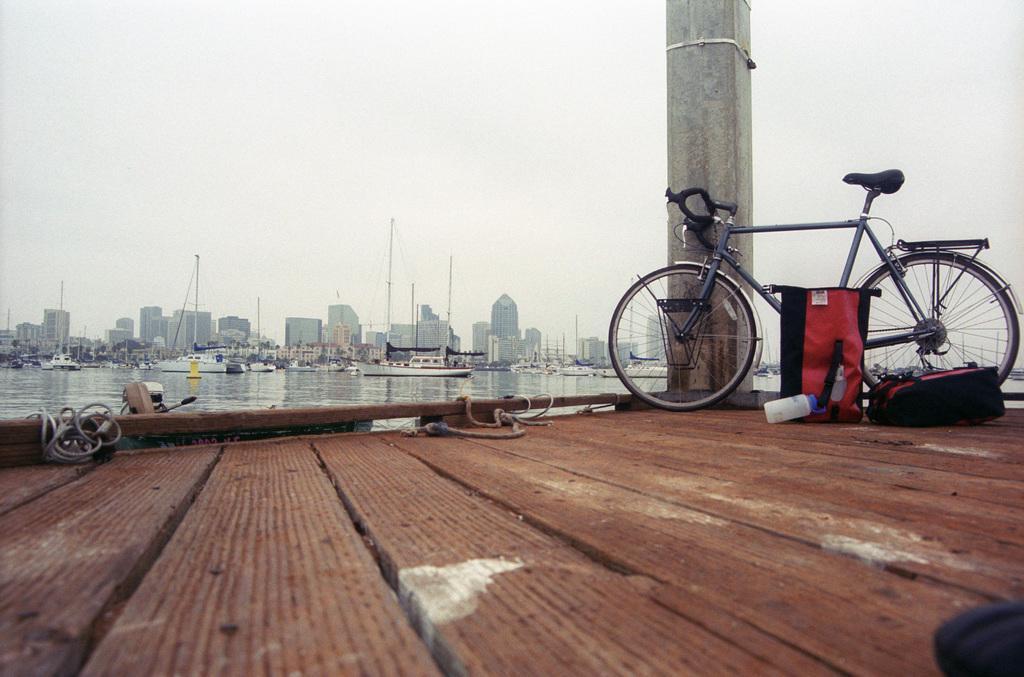In one or two sentences, can you explain what this image depicts? In this image we can see many buildings and few watercraft vehicles. A bike is parked beside a pillar on a wooden floor. 